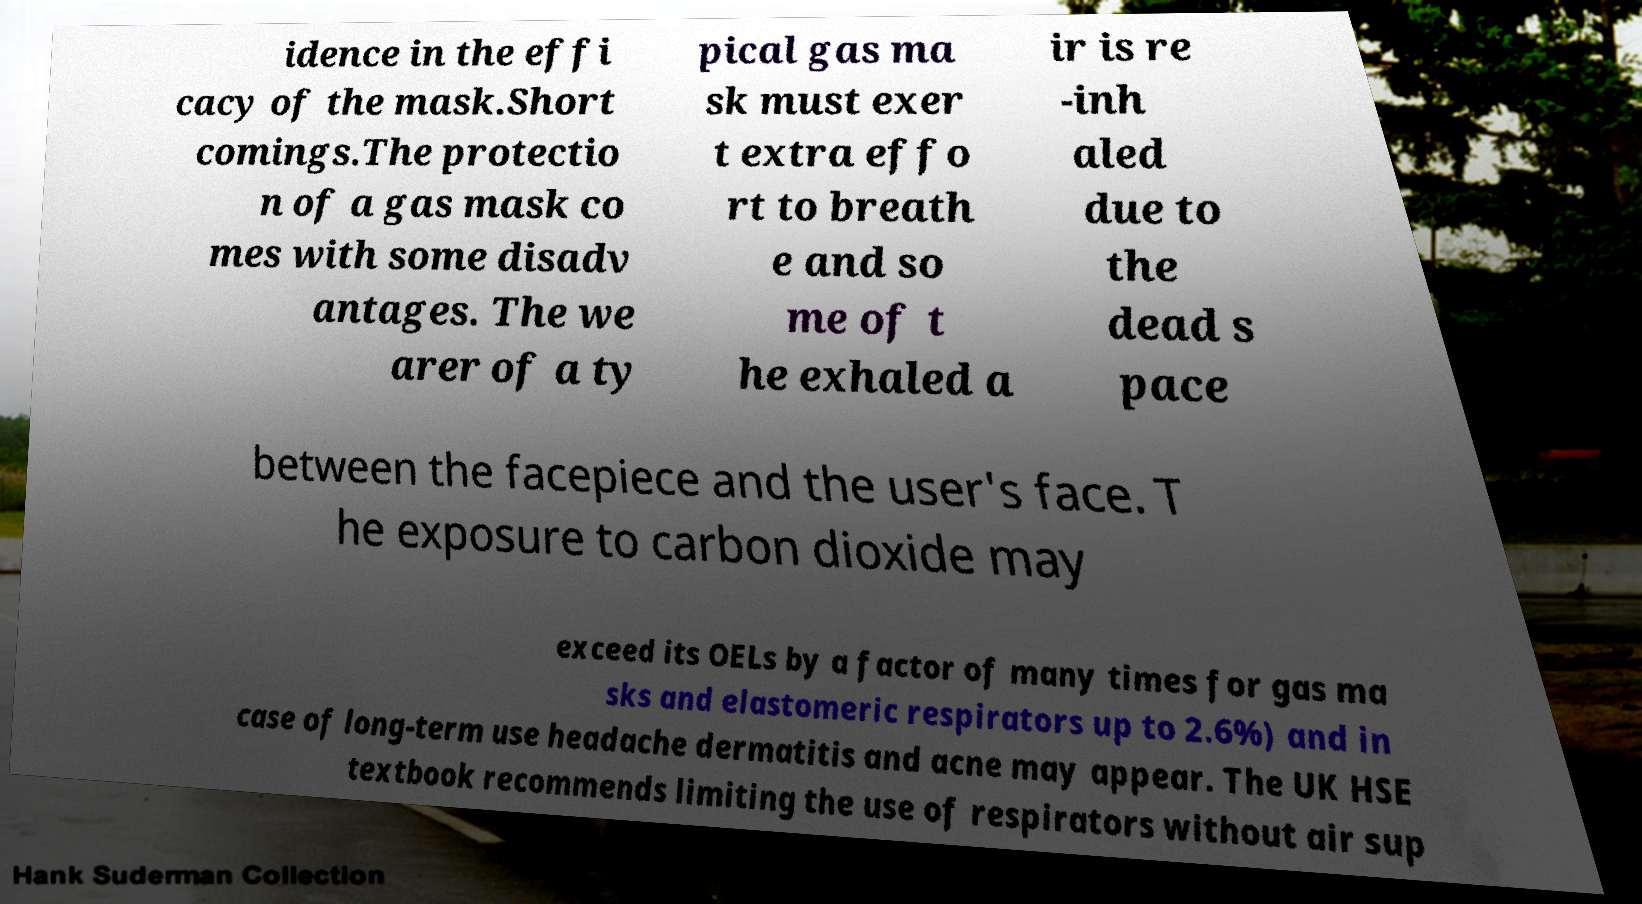Could you extract and type out the text from this image? idence in the effi cacy of the mask.Short comings.The protectio n of a gas mask co mes with some disadv antages. The we arer of a ty pical gas ma sk must exer t extra effo rt to breath e and so me of t he exhaled a ir is re -inh aled due to the dead s pace between the facepiece and the user's face. T he exposure to carbon dioxide may exceed its OELs by a factor of many times for gas ma sks and elastomeric respirators up to 2.6%) and in case of long-term use headache dermatitis and acne may appear. The UK HSE textbook recommends limiting the use of respirators without air sup 